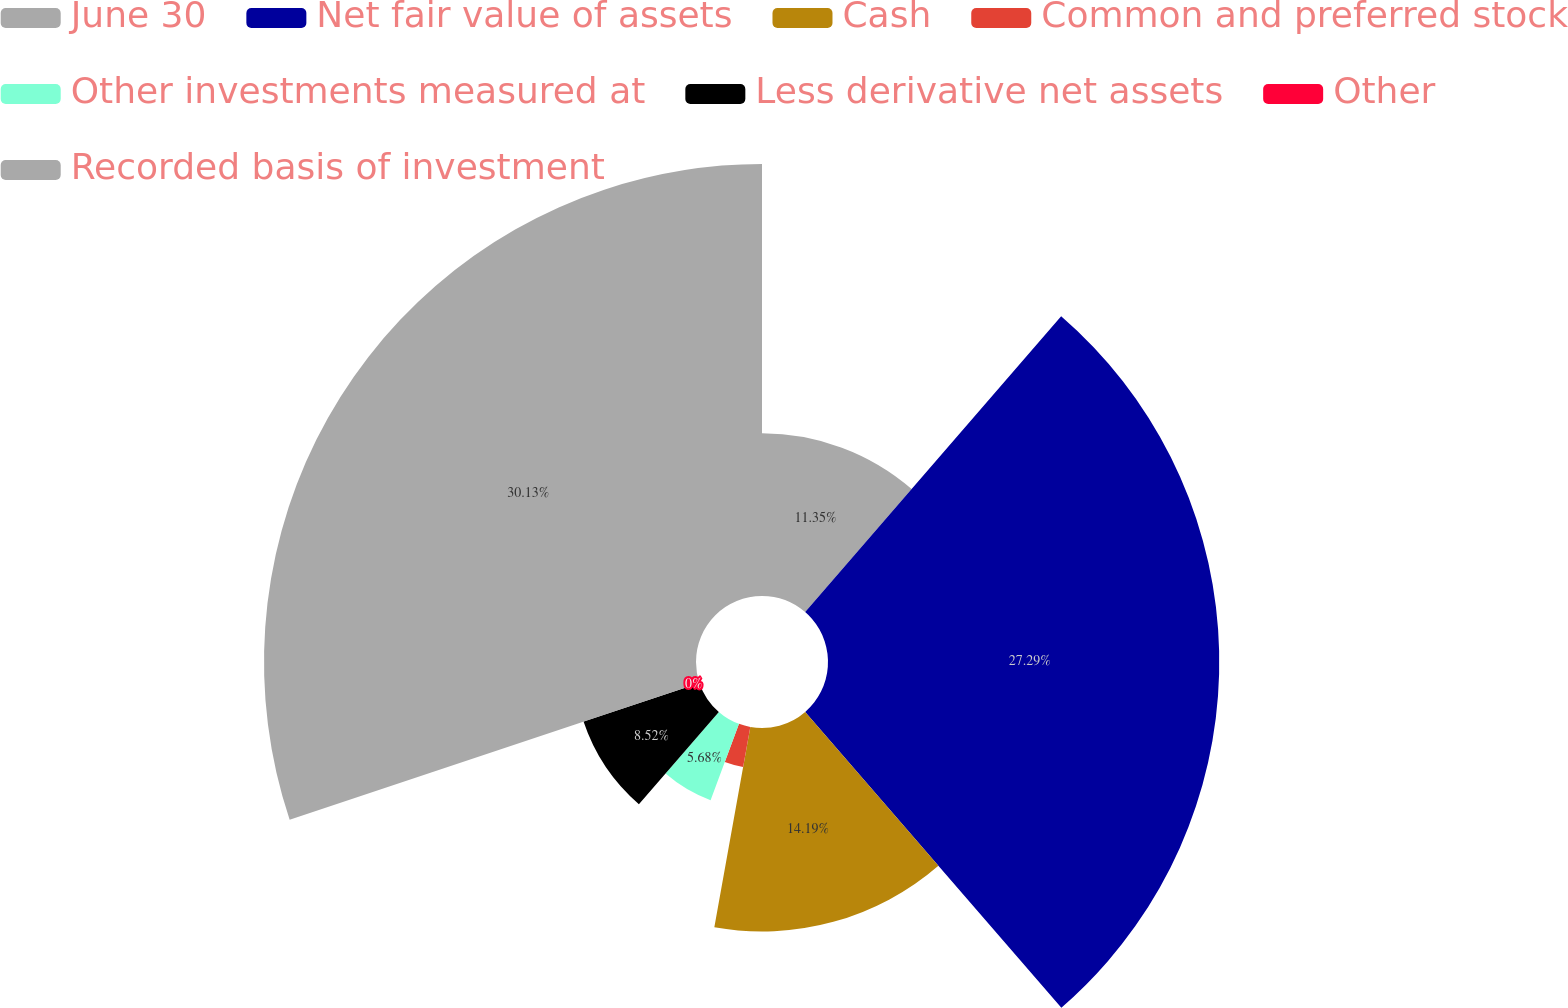Convert chart. <chart><loc_0><loc_0><loc_500><loc_500><pie_chart><fcel>June 30<fcel>Net fair value of assets<fcel>Cash<fcel>Common and preferred stock<fcel>Other investments measured at<fcel>Less derivative net assets<fcel>Other<fcel>Recorded basis of investment<nl><fcel>11.35%<fcel>27.29%<fcel>14.19%<fcel>2.84%<fcel>5.68%<fcel>8.52%<fcel>0.0%<fcel>30.13%<nl></chart> 